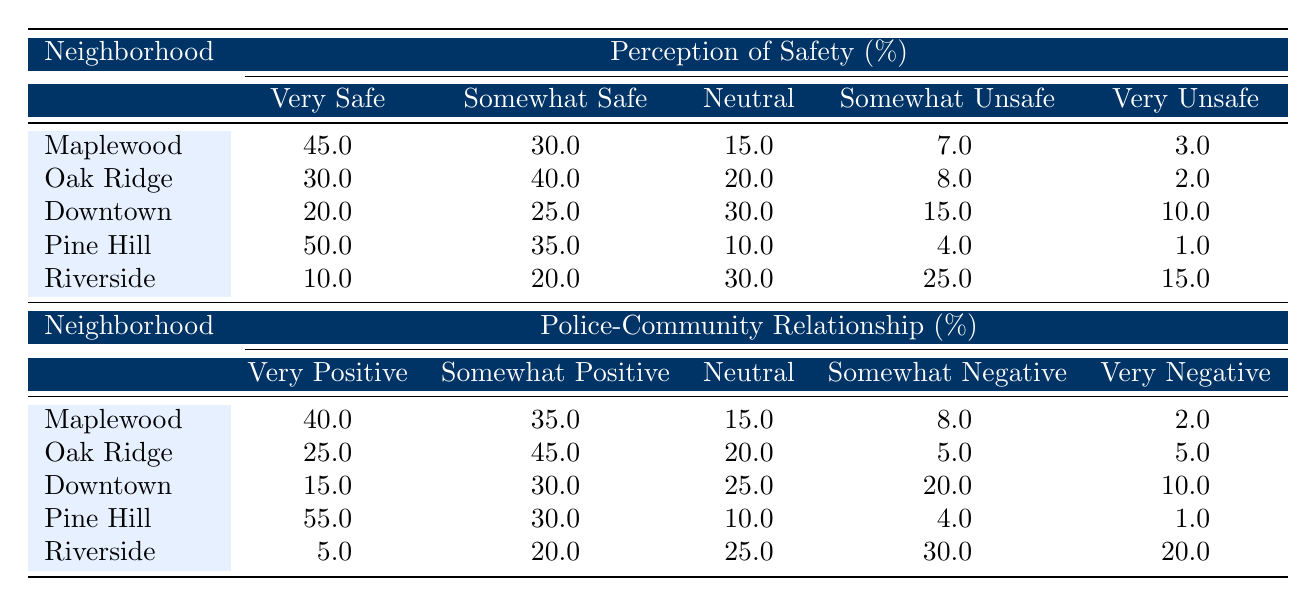What percentage of community members in Pine Hill feel very safe? In the Pine Hill row of the table, under the "Perception of Safety (%)" section, the percentage listed for "Very Safe" is 50.0%
Answer: 50.0% Which neighborhood has the highest percentage of somewhat unsafe perceptions of safety? By looking at the "Somewhat Unsafe" column, Riverside has the highest percentage, at 25.0%.
Answer: Riverside What is the total percentage of community members in Oak Ridge who feel either very safe or somewhat safe? In the Oak Ridge row for perception of safety, the percentage for "Very Safe" is 30.0% and for "Somewhat Safe" is 40.0%. Adding these together gives 30.0 + 40.0 = 70.0%.
Answer: 70.0% Is it true that Downtown has a greater percentage of community members feeling "very unsafe" than "very positive" towards police-community relationships? In Downtown, the percentage of "Very Unsafe" is 10.0% and the percentage of "Very Positive" is 15.0%. Since 10.0% is less than 15.0%, the statement is false.
Answer: No What is the difference in the percentage of very positive police-community relationships between Maplewood and Riverside? In the Maplewood row, the percentage for "Very Positive" is 40.0%, and in the Riverside row, it is 5.0%. The difference is calculated as 40.0 - 5.0 = 35.0%.
Answer: 35.0% 